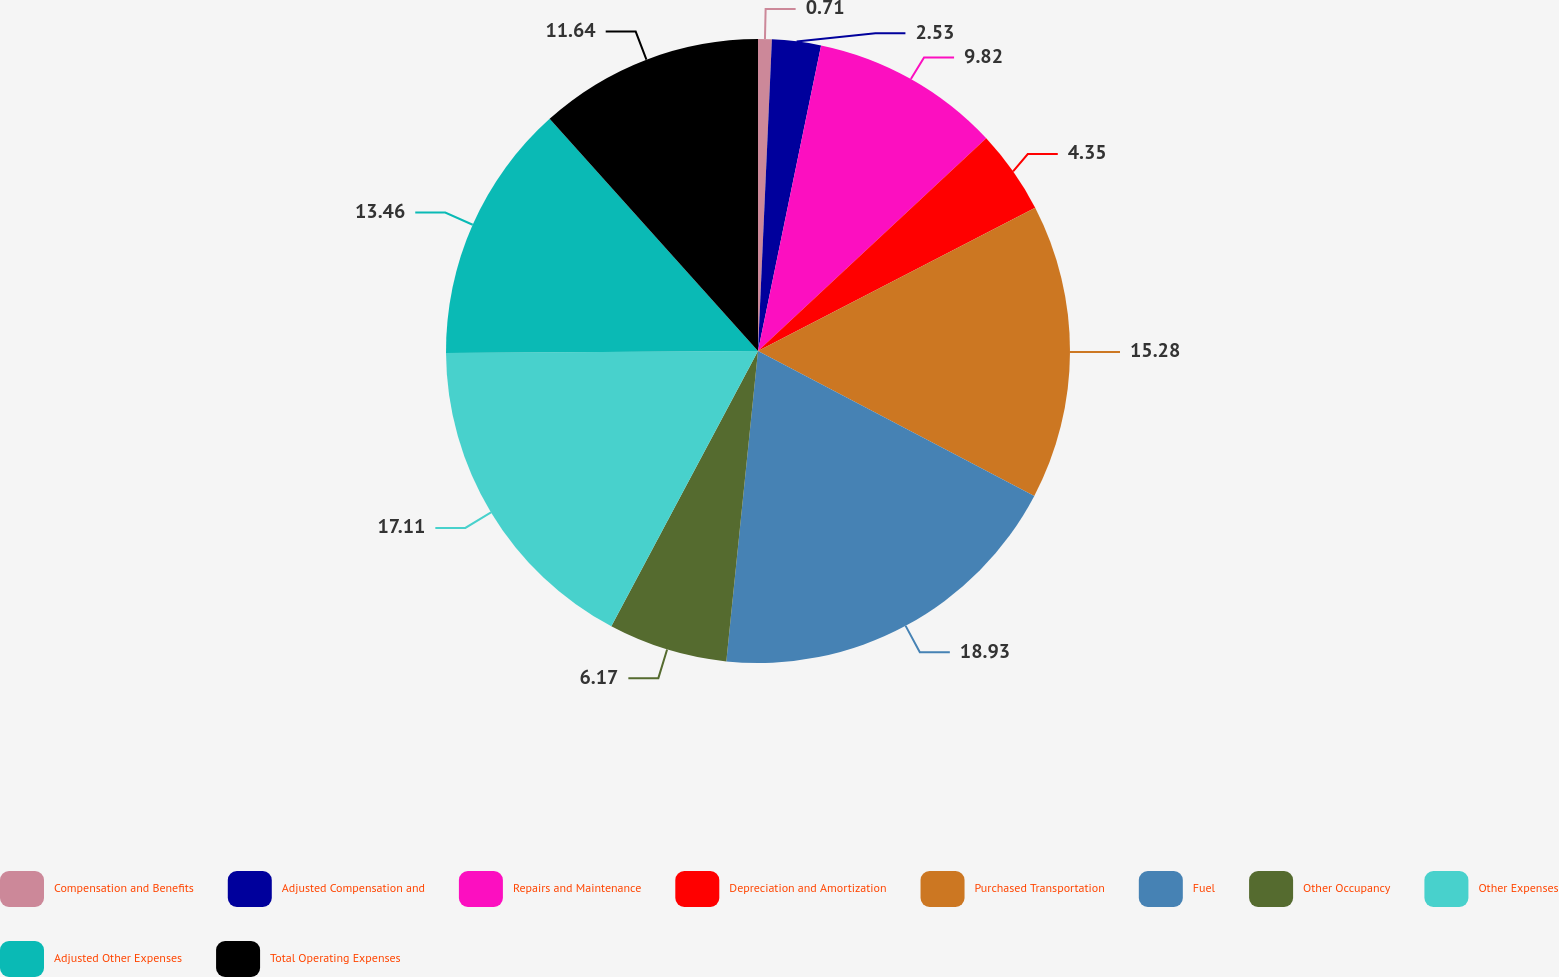<chart> <loc_0><loc_0><loc_500><loc_500><pie_chart><fcel>Compensation and Benefits<fcel>Adjusted Compensation and<fcel>Repairs and Maintenance<fcel>Depreciation and Amortization<fcel>Purchased Transportation<fcel>Fuel<fcel>Other Occupancy<fcel>Other Expenses<fcel>Adjusted Other Expenses<fcel>Total Operating Expenses<nl><fcel>0.71%<fcel>2.53%<fcel>9.82%<fcel>4.35%<fcel>15.28%<fcel>18.93%<fcel>6.17%<fcel>17.11%<fcel>13.46%<fcel>11.64%<nl></chart> 